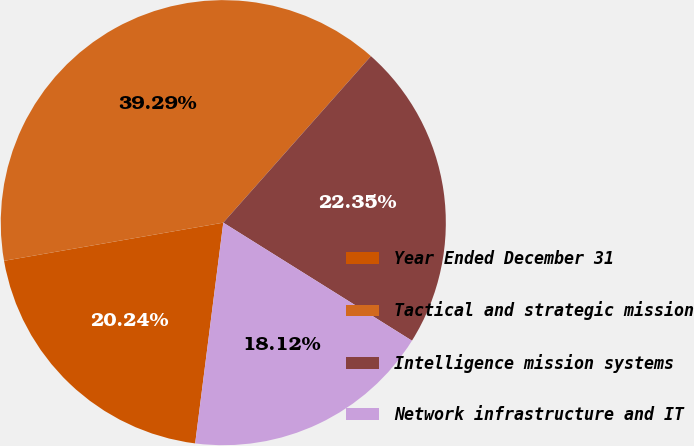Convert chart to OTSL. <chart><loc_0><loc_0><loc_500><loc_500><pie_chart><fcel>Year Ended December 31<fcel>Tactical and strategic mission<fcel>Intelligence mission systems<fcel>Network infrastructure and IT<nl><fcel>20.24%<fcel>39.29%<fcel>22.35%<fcel>18.12%<nl></chart> 